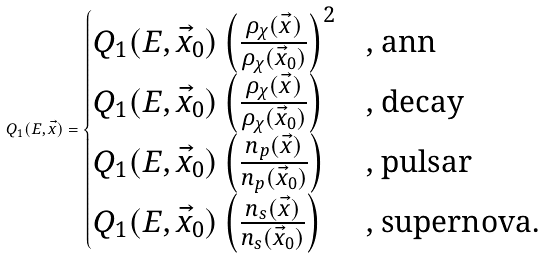<formula> <loc_0><loc_0><loc_500><loc_500>Q _ { 1 } ( E , \vec { x } ) = \begin{cases} Q _ { 1 } ( E , \vec { x } _ { 0 } ) \left ( \frac { \rho _ { \chi } ( \vec { x } ) } { \rho _ { \chi } ( \vec { x } _ { 0 } ) } \right ) ^ { 2 } & \text {, ann} \\ Q _ { 1 } ( E , \vec { x } _ { 0 } ) \left ( \frac { \rho _ { \chi } ( \vec { x } ) } { \rho _ { \chi } ( \vec { x } _ { 0 } ) } \right ) & \text {, decay} \\ Q _ { 1 } ( E , \vec { x } _ { 0 } ) \left ( \frac { n _ { p } ( \vec { x } ) } { n _ { p } ( \vec { x } _ { 0 } ) } \right ) & \text {, pulsar} \\ Q _ { 1 } ( E , \vec { x } _ { 0 } ) \left ( \frac { n _ { s } ( \vec { x } ) } { n _ { s } ( \vec { x } _ { 0 } ) } \right ) & \text {, supernova.} \end{cases}</formula> 